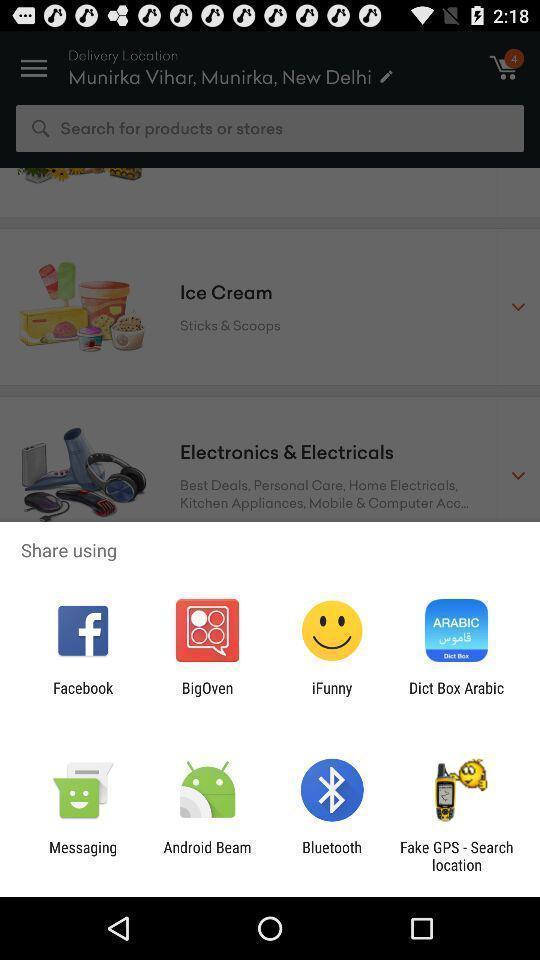What details can you identify in this image? Pop-up to share using different apps. 